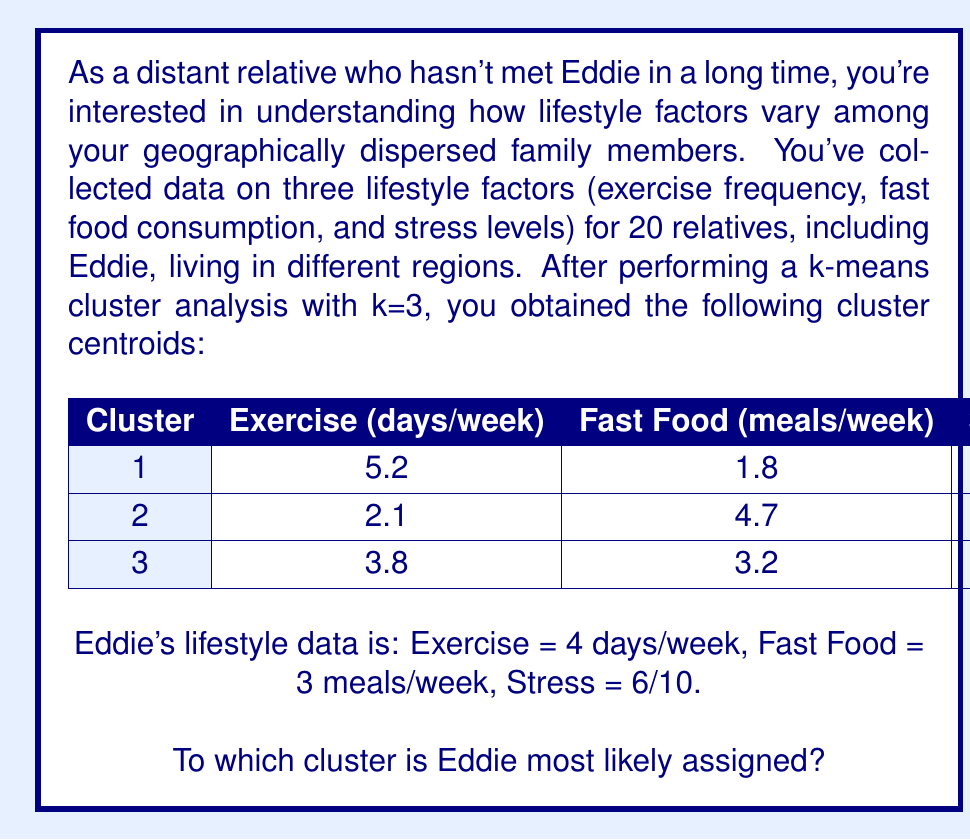Help me with this question. To determine which cluster Eddie is most likely assigned to, we need to calculate the Euclidean distance between Eddie's data point and each cluster centroid. The cluster with the smallest distance will be the one Eddie is assigned to.

Let's calculate the distance to each cluster:

1. Distance to Cluster 1:
   $$d_1 = \sqrt{(4-5.2)^2 + (3-1.8)^2 + (6-4.5)^2}$$
   $$d_1 = \sqrt{(-1.2)^2 + 1.2^2 + 1.5^2}$$
   $$d_1 = \sqrt{1.44 + 1.44 + 2.25} = \sqrt{5.13} \approx 2.26$$

2. Distance to Cluster 2:
   $$d_2 = \sqrt{(4-2.1)^2 + (3-4.7)^2 + (6-7.3)^2}$$
   $$d_2 = \sqrt{1.9^2 + (-1.7)^2 + (-1.3)^2}$$
   $$d_2 = \sqrt{3.61 + 2.89 + 1.69} = \sqrt{8.19} \approx 2.86$$

3. Distance to Cluster 3:
   $$d_3 = \sqrt{(4-3.8)^2 + (3-3.2)^2 + (6-5.9)^2}$$
   $$d_3 = \sqrt{0.2^2 + (-0.2)^2 + 0.1^2}$$
   $$d_3 = \sqrt{0.04 + 0.04 + 0.01} = \sqrt{0.09} = 0.3$$

The smallest distance is to Cluster 3 (0.3), so Eddie is most likely assigned to this cluster.
Answer: Cluster 3 